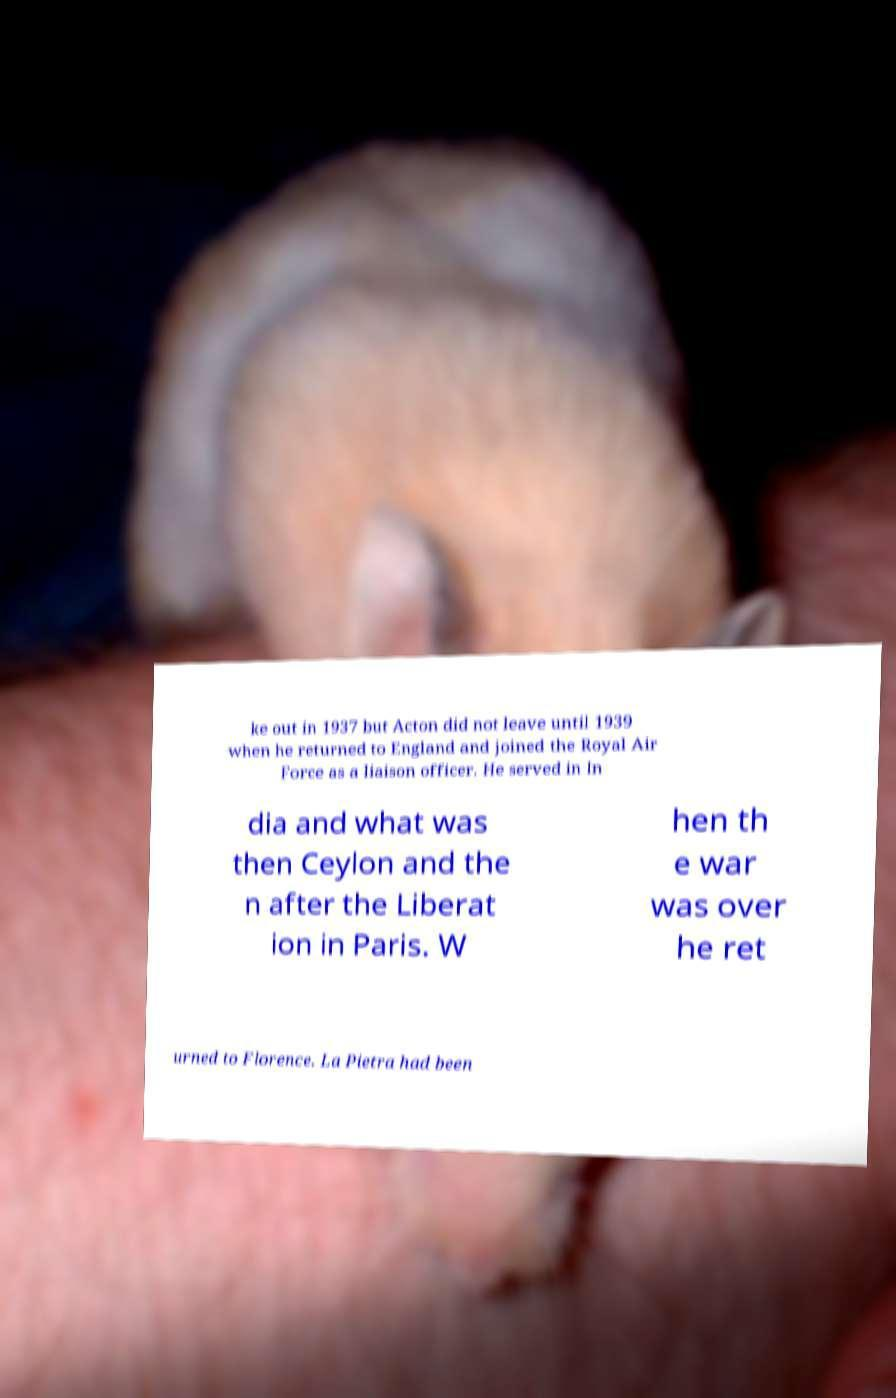There's text embedded in this image that I need extracted. Can you transcribe it verbatim? ke out in 1937 but Acton did not leave until 1939 when he returned to England and joined the Royal Air Force as a liaison officer. He served in In dia and what was then Ceylon and the n after the Liberat ion in Paris. W hen th e war was over he ret urned to Florence. La Pietra had been 